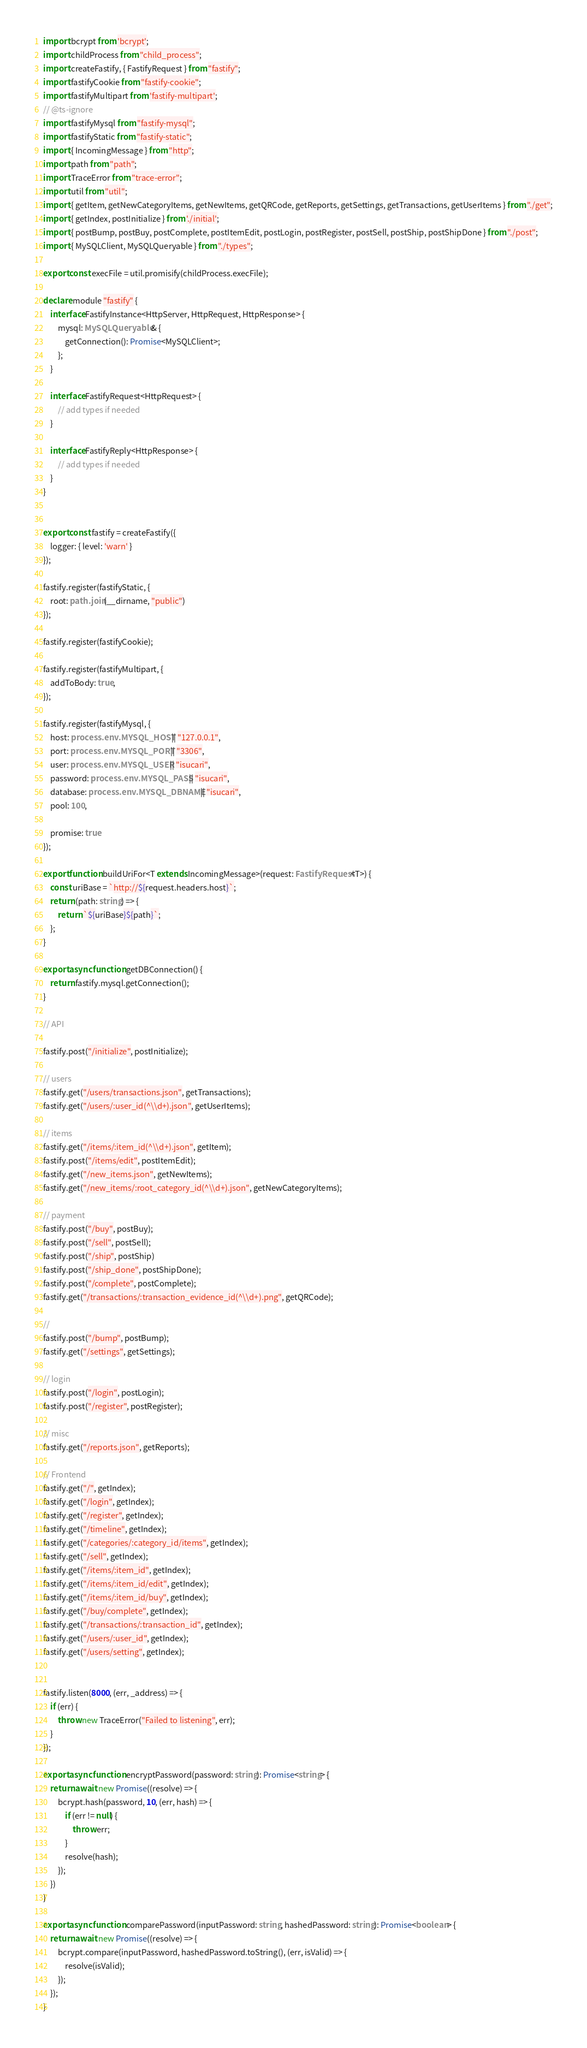<code> <loc_0><loc_0><loc_500><loc_500><_TypeScript_>import bcrypt from 'bcrypt';
import childProcess from "child_process";
import createFastify, { FastifyRequest } from "fastify";
import fastifyCookie from "fastify-cookie";
import fastifyMultipart from 'fastify-multipart';
// @ts-ignore
import fastifyMysql from "fastify-mysql";
import fastifyStatic from "fastify-static";
import { IncomingMessage } from "http";
import path from "path";
import TraceError from "trace-error";
import util from "util";
import { getItem, getNewCategoryItems, getNewItems, getQRCode, getReports, getSettings, getTransactions, getUserItems } from "./get";
import { getIndex, postInitialize } from './initial';
import { postBump, postBuy, postComplete, postItemEdit, postLogin, postRegister, postSell, postShip, postShipDone } from "./post";
import { MySQLClient, MySQLQueryable } from "./types";

export const execFile = util.promisify(childProcess.execFile);

declare module "fastify" {
    interface FastifyInstance<HttpServer, HttpRequest, HttpResponse> {
        mysql: MySQLQueryable & {
            getConnection(): Promise<MySQLClient>;
        };
    }

    interface FastifyRequest<HttpRequest> {
        // add types if needed
    }

    interface FastifyReply<HttpResponse> {
        // add types if needed
    }
}


export const fastify = createFastify({
    logger: { level: 'warn' }
});

fastify.register(fastifyStatic, {
    root: path.join(__dirname, "public")
});

fastify.register(fastifyCookie);

fastify.register(fastifyMultipart, {
    addToBody: true,
});

fastify.register(fastifyMysql, {
    host: process.env.MYSQL_HOST || "127.0.0.1",
    port: process.env.MYSQL_PORT || "3306",
    user: process.env.MYSQL_USER || "isucari",
    password: process.env.MYSQL_PASS || "isucari",
    database: process.env.MYSQL_DBNAME || "isucari",
    pool: 100,

    promise: true
});

export function buildUriFor<T extends IncomingMessage>(request: FastifyRequest<T>) {
    const uriBase = `http://${request.headers.host}`;
    return (path: string) => {
        return `${uriBase}${path}`;
    };
}

export async function getDBConnection() {
    return fastify.mysql.getConnection();
}

// API

fastify.post("/initialize", postInitialize);

// users
fastify.get("/users/transactions.json", getTransactions);
fastify.get("/users/:user_id(^\\d+).json", getUserItems);

// items
fastify.get("/items/:item_id(^\\d+).json", getItem);
fastify.post("/items/edit", postItemEdit);
fastify.get("/new_items.json", getNewItems);
fastify.get("/new_items/:root_category_id(^\\d+).json", getNewCategoryItems);

// payment
fastify.post("/buy", postBuy);
fastify.post("/sell", postSell);
fastify.post("/ship", postShip)
fastify.post("/ship_done", postShipDone);
fastify.post("/complete", postComplete);
fastify.get("/transactions/:transaction_evidence_id(^\\d+).png", getQRCode);

// 
fastify.post("/bump", postBump);
fastify.get("/settings", getSettings);

// login
fastify.post("/login", postLogin);
fastify.post("/register", postRegister);

// misc
fastify.get("/reports.json", getReports);

// Frontend
fastify.get("/", getIndex);
fastify.get("/login", getIndex);
fastify.get("/register", getIndex);
fastify.get("/timeline", getIndex);
fastify.get("/categories/:category_id/items", getIndex);
fastify.get("/sell", getIndex);
fastify.get("/items/:item_id", getIndex);
fastify.get("/items/:item_id/edit", getIndex);
fastify.get("/items/:item_id/buy", getIndex);
fastify.get("/buy/complete", getIndex);
fastify.get("/transactions/:transaction_id", getIndex);
fastify.get("/users/:user_id", getIndex);
fastify.get("/users/setting", getIndex);


fastify.listen(8000, (err, _address) => {
    if (err) {
        throw new TraceError("Failed to listening", err);
    }
});

export async function encryptPassword(password: string): Promise<string> {
    return await new Promise((resolve) => {
        bcrypt.hash(password, 10, (err, hash) => {
            if (err != null) {
                throw err;
            }
            resolve(hash);
        });
    })
}

export async function comparePassword(inputPassword: string, hashedPassword: string): Promise<boolean> {
    return await new Promise((resolve) => {
        bcrypt.compare(inputPassword, hashedPassword.toString(), (err, isValid) => {
            resolve(isValid);
        });
    });
}

</code> 